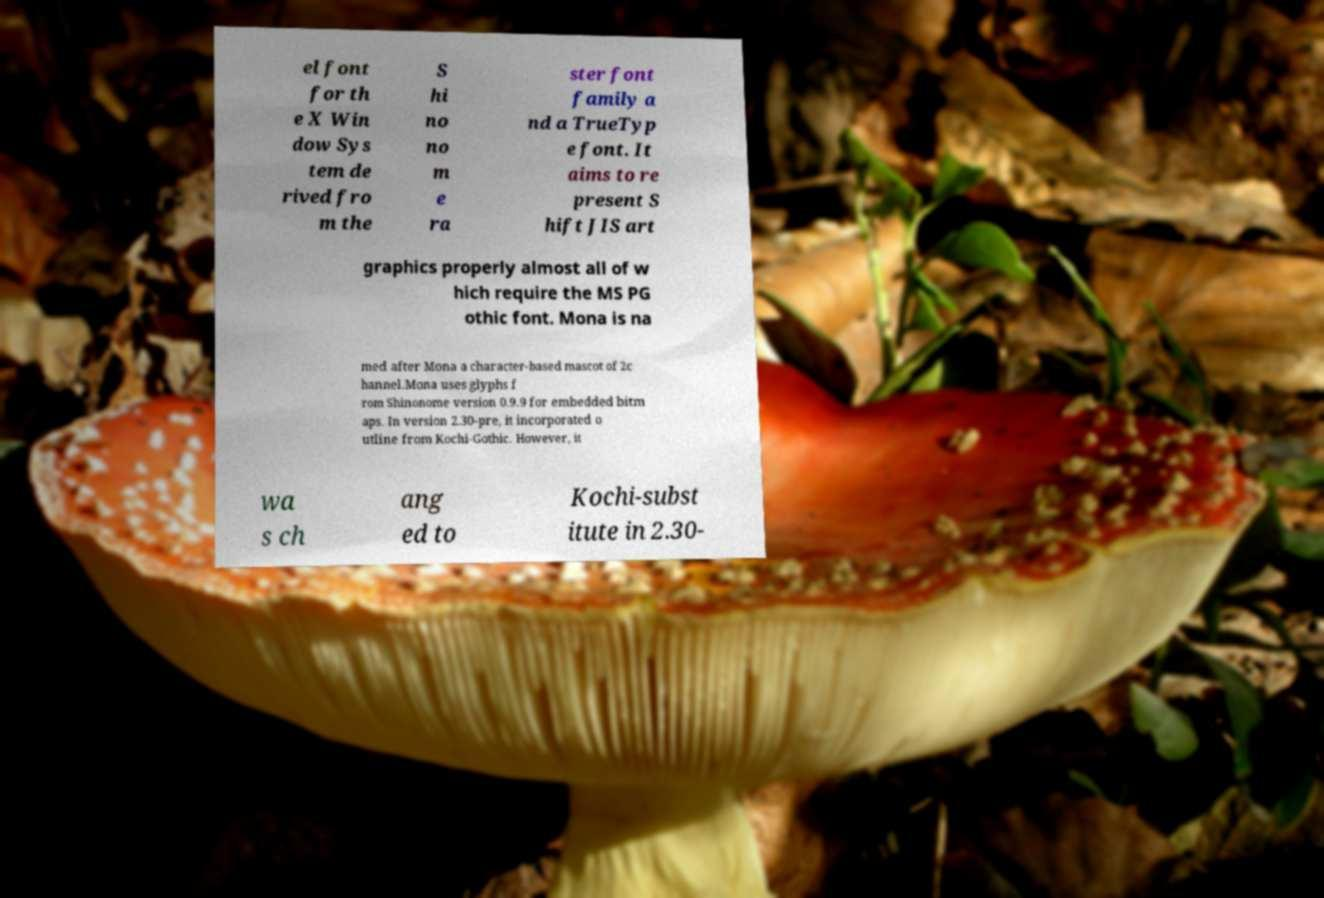Please identify and transcribe the text found in this image. el font for th e X Win dow Sys tem de rived fro m the S hi no no m e ra ster font family a nd a TrueTyp e font. It aims to re present S hift JIS art graphics properly almost all of w hich require the MS PG othic font. Mona is na med after Mona a character-based mascot of 2c hannel.Mona uses glyphs f rom Shinonome version 0.9.9 for embedded bitm aps. In version 2.30-pre, it incorporated o utline from Kochi-Gothic. However, it wa s ch ang ed to Kochi-subst itute in 2.30- 